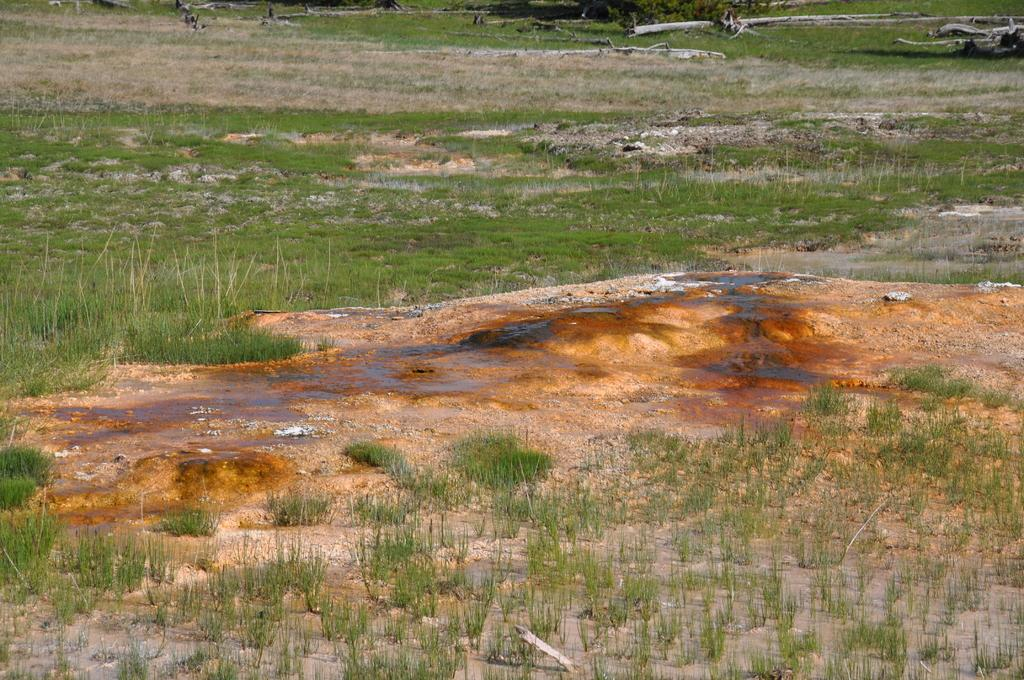What type of natural environment is depicted in the image? There is grass on the ground in the image. What other natural elements can be seen in the image? There are tree trunks visible in the image. What type of industry can be seen operating in the background of the image? There is no industry present in the image; it features grass and tree trunks. What type of linen is draped over the tree trunks in the image? There is no linen present in the image; it features grass and tree trunks. 